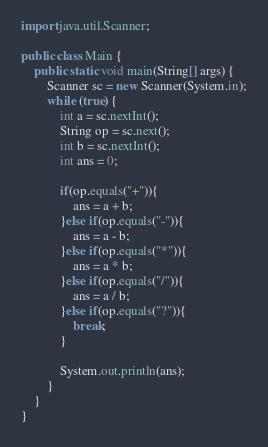Convert code to text. <code><loc_0><loc_0><loc_500><loc_500><_Java_>import java.util.Scanner;

public class Main {
    public static void main(String[] args) {
        Scanner sc = new Scanner(System.in);
        while (true) {
            int a = sc.nextInt();
            String op = sc.next();
            int b = sc.nextInt();
            int ans = 0;

            if(op.equals("+")){
                ans = a + b;
            }else if(op.equals("-")){
                ans = a - b;
            }else if(op.equals("*")){
                ans = a * b;
            }else if(op.equals("/")){
                ans = a / b;
            }else if(op.equals("?")){
                break;
            }
            
            System.out.println(ans);
        }
    }
}
</code> 